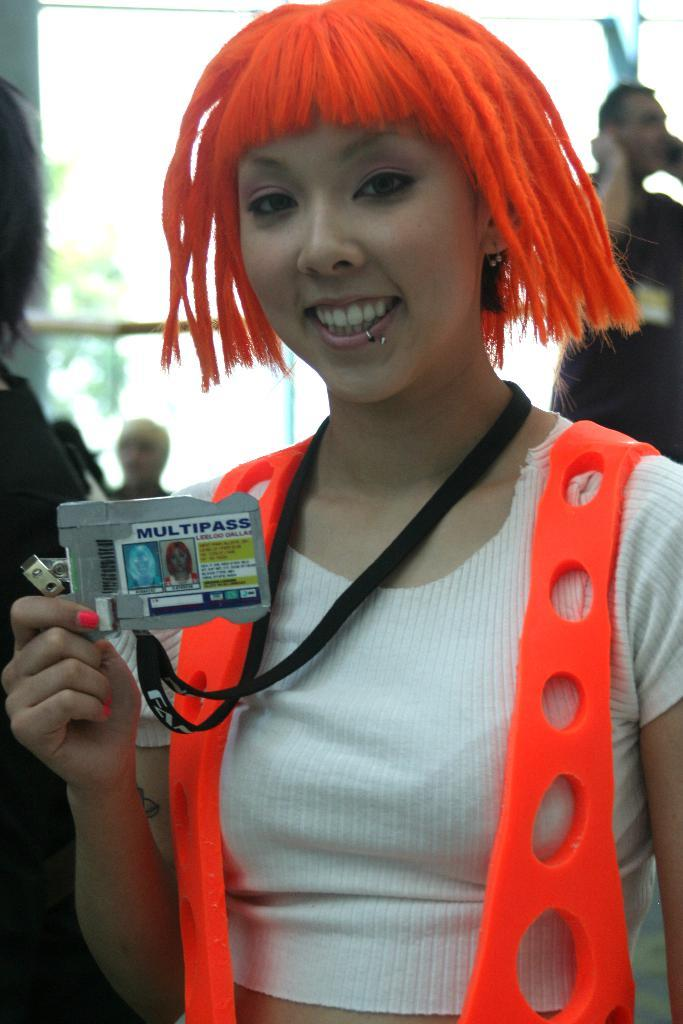What is the main subject of the image? There is a person in the image. What is the person wearing? The person is wearing a white top. What is the person holding in the image? The person is holding a batch. Can you describe the people in the background of the image? The people in the background are visible but blurred. What is the price of the chairs in the image? There are no chairs present in the image, so it is not possible to determine their price. 